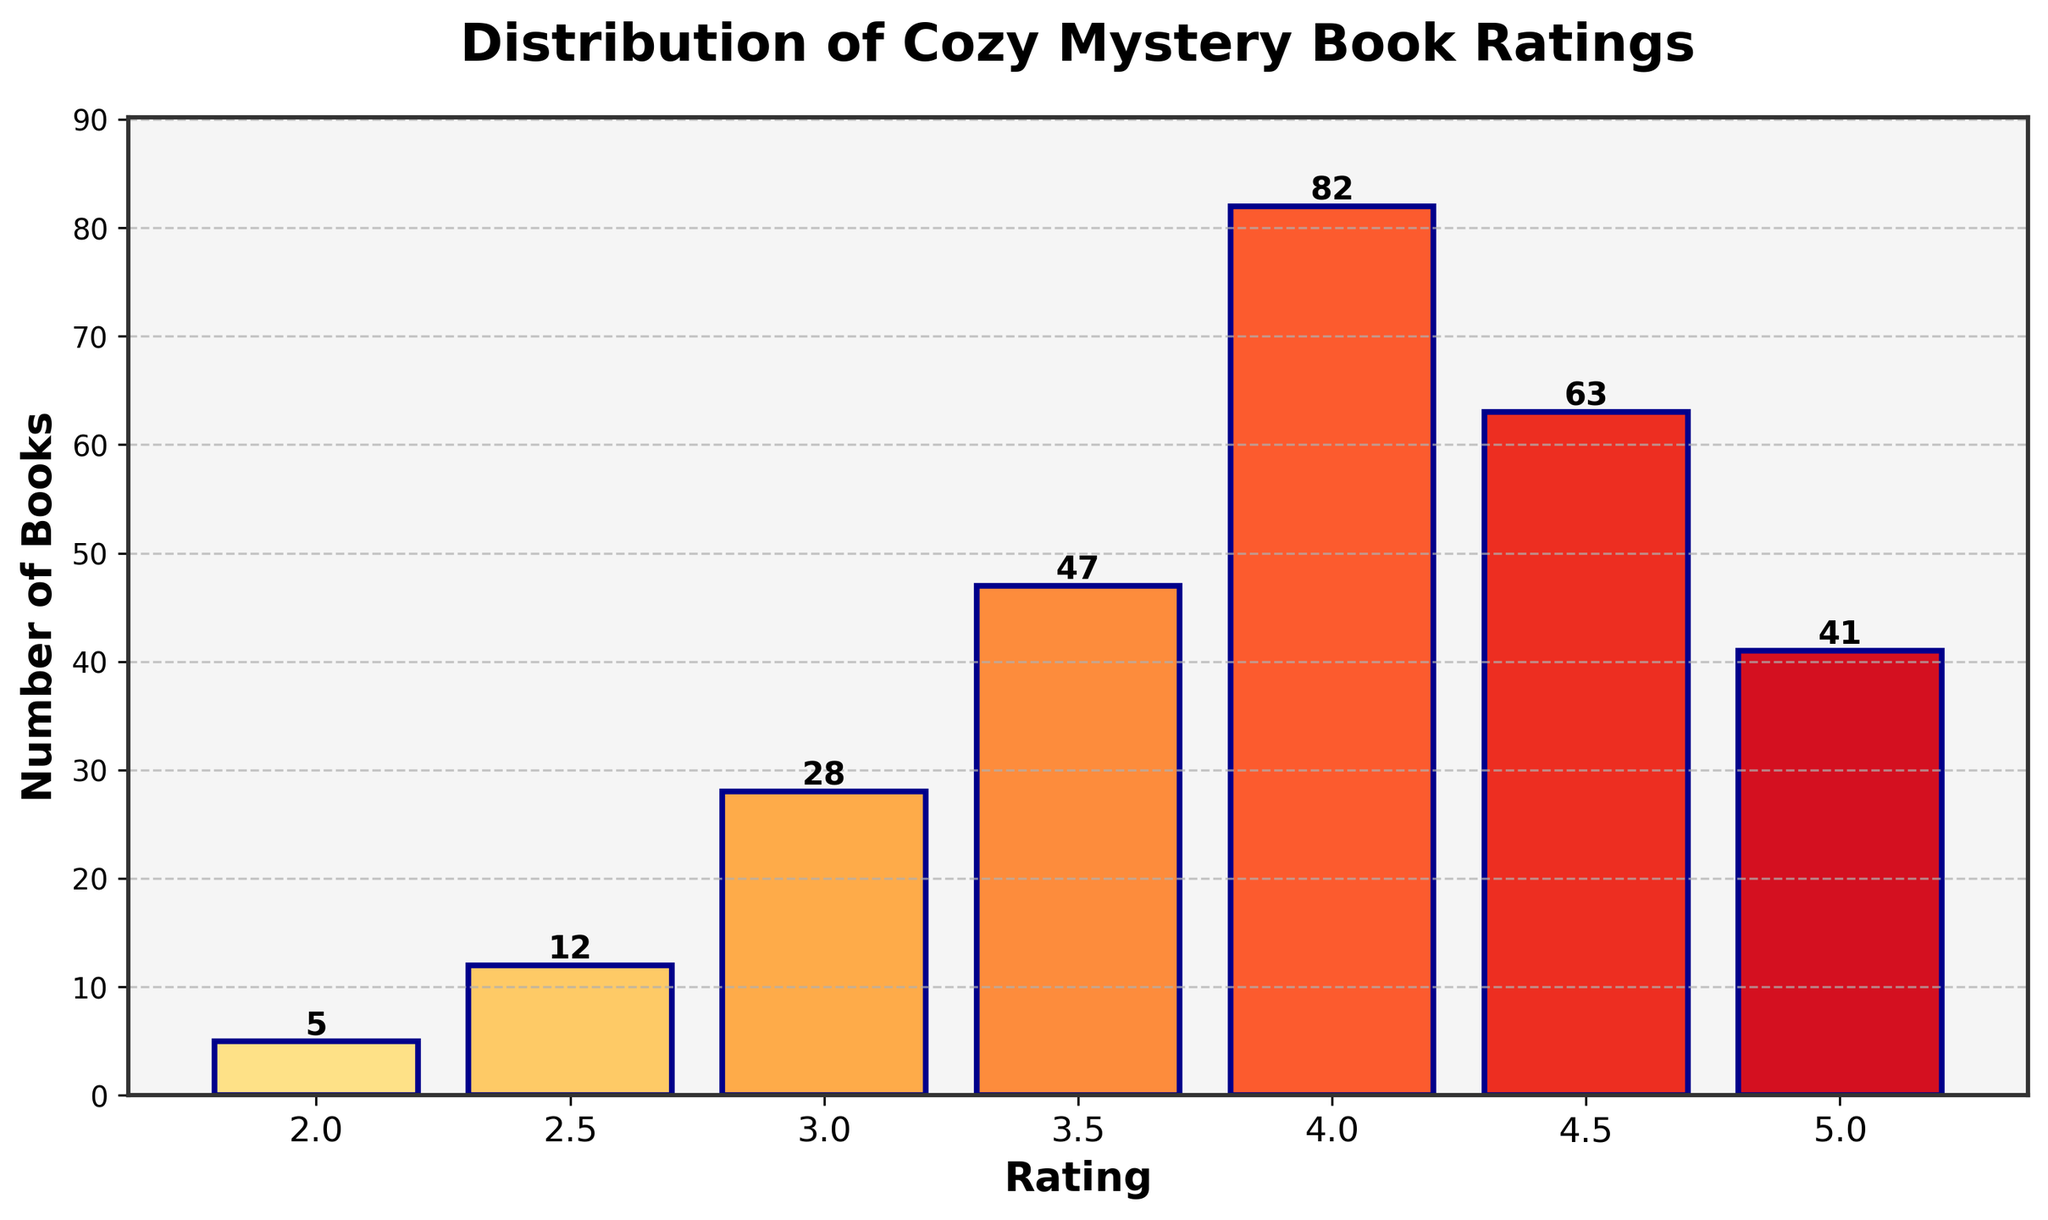What is the title of the histogram? The title is typically located at the top of the figure. In this case, it reads "Distribution of Cozy Mystery Book Ratings".
Answer: Distribution of Cozy Mystery Book Ratings What rating has the highest number of books? Observe the figure and find the tallest bar, which corresponds to the highest number of books. The tallest bar is at "4.0" with 82 books.
Answer: 4.0 How many books have a 2.5-star rating? Look at the bar corresponding to the "2.5" rating. The figure at the top of this bar shows "12" books.
Answer: 12 Which rating range has the second-highest number of books? Identify the bar with the second-highest height after the tallest bar (4.0 with 82 books). The next highest bar is at "4.5" with 63 books.
Answer: 4.5 What is the total number of books rated 3.0 or 3.5 stars? Add the number of books for the 3.0 and 3.5 ratings. For 3.0 stars, there are 28 books, and for 3.5 stars, there are 47 books. So, 28 + 47 = 75 books in total.
Answer: 75 Is the number of books rated 5.0 more than those rated 2.5? Compare the two bars corresponding to the 2.5 and 5.0 ratings. There are 12 books at 2.5 stars and 41 books at 5.0 stars, so the number of books rated 5.0 is more.
Answer: Yes What's the range of ratings covered in the histogram? Look at the x-axis and observe the lowest and highest ratings plotted. The lowest rating is 2.0 and the highest is 5.0, making the range from 2.0 to 5.0.
Answer: 2.0 to 5.0 Which rating has fewer books, 4.5 or 5.0? Compare the bars at 4.5 and 5.0 ratings. The 4.5 rating has 63 books and the 5.0 rating has 41 books. Therefore, 5.0 stars have fewer books than 4.5 stars.
Answer: 5.0 How many ratings have more than 50 books? Identify the bars with heights greater than 50. The ratings that meet this criterion are 4.0 (82 books) and 4.5 (63 books). So there are two ratings with more than 50 books.
Answer: 2 